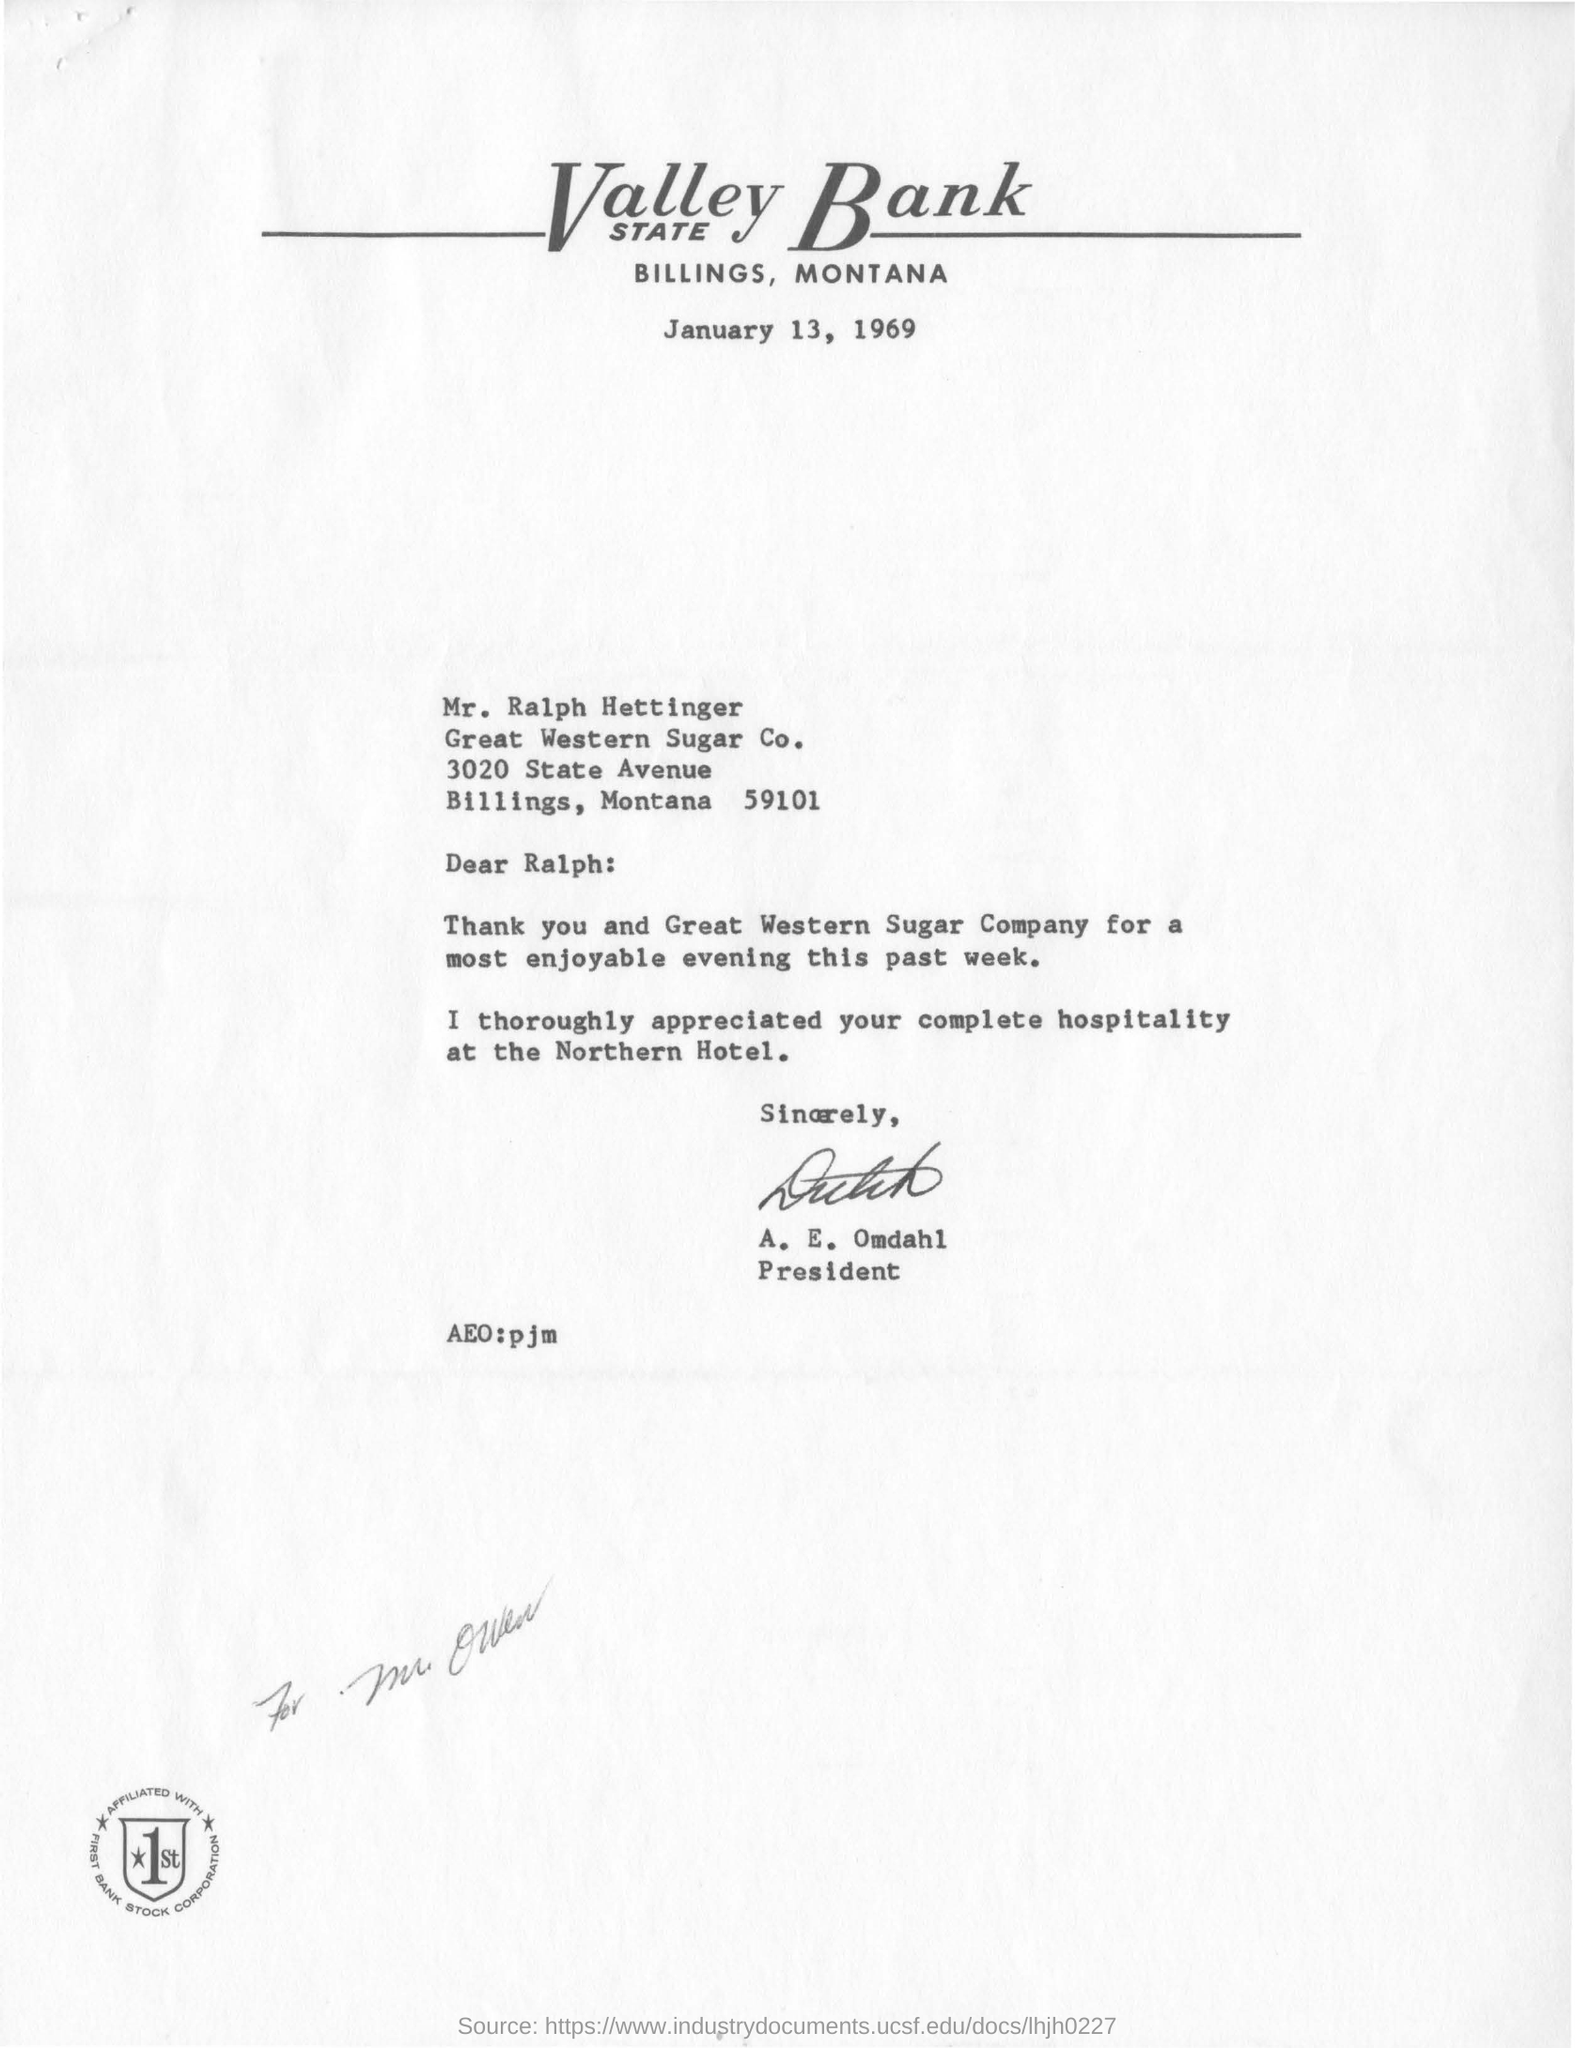Specify some key components in this picture. The date written on the letter is January 13, 1969. The letter is addressed to Ralph. The letter is from A. E. Omdahl. The letter has been signed by E. Omdahl. 